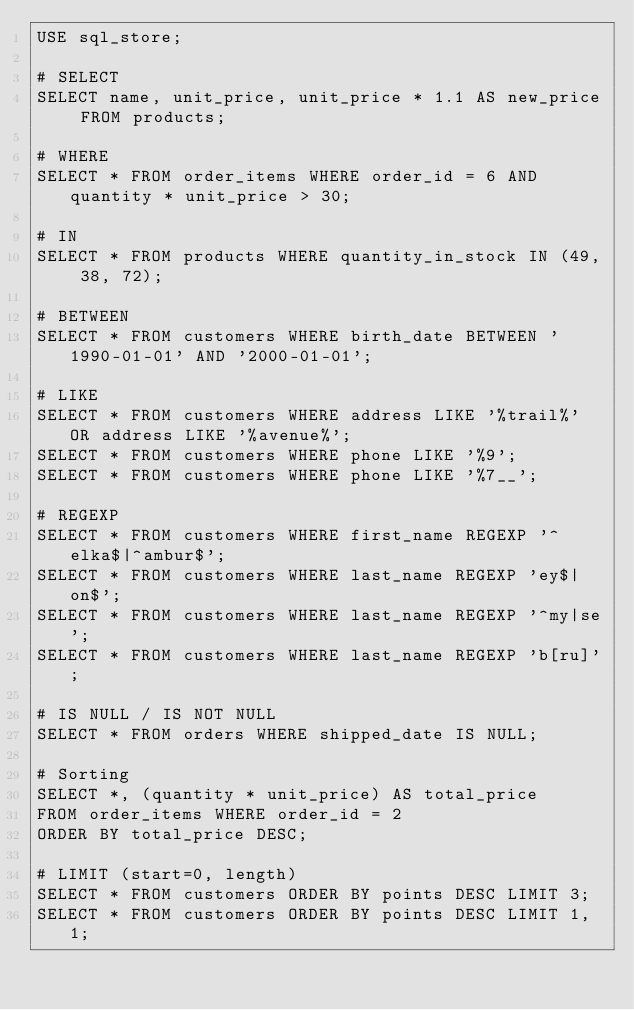Convert code to text. <code><loc_0><loc_0><loc_500><loc_500><_SQL_>USE sql_store;

# SELECT
SELECT name, unit_price, unit_price * 1.1 AS new_price FROM products;

# WHERE
SELECT * FROM order_items WHERE order_id = 6 AND quantity * unit_price > 30;

# IN
SELECT * FROM products WHERE quantity_in_stock IN (49, 38, 72);

# BETWEEN
SELECT * FROM customers WHERE birth_date BETWEEN '1990-01-01' AND '2000-01-01';

# LIKE
SELECT * FROM customers WHERE address LIKE '%trail%' OR address LIKE '%avenue%';
SELECT * FROM customers WHERE phone LIKE '%9';
SELECT * FROM customers WHERE phone LIKE '%7__';

# REGEXP
SELECT * FROM customers WHERE first_name REGEXP '^elka$|^ambur$';
SELECT * FROM customers WHERE last_name REGEXP 'ey$|on$';
SELECT * FROM customers WHERE last_name REGEXP '^my|se';
SELECT * FROM customers WHERE last_name REGEXP 'b[ru]';

# IS NULL / IS NOT NULL
SELECT * FROM orders WHERE shipped_date IS NULL;

# Sorting
SELECT *, (quantity * unit_price) AS total_price 
FROM order_items WHERE order_id = 2 
ORDER BY total_price DESC;

# LIMIT (start=0, length)
SELECT * FROM customers ORDER BY points DESC LIMIT 3;
SELECT * FROM customers ORDER BY points DESC LIMIT 1, 1;</code> 